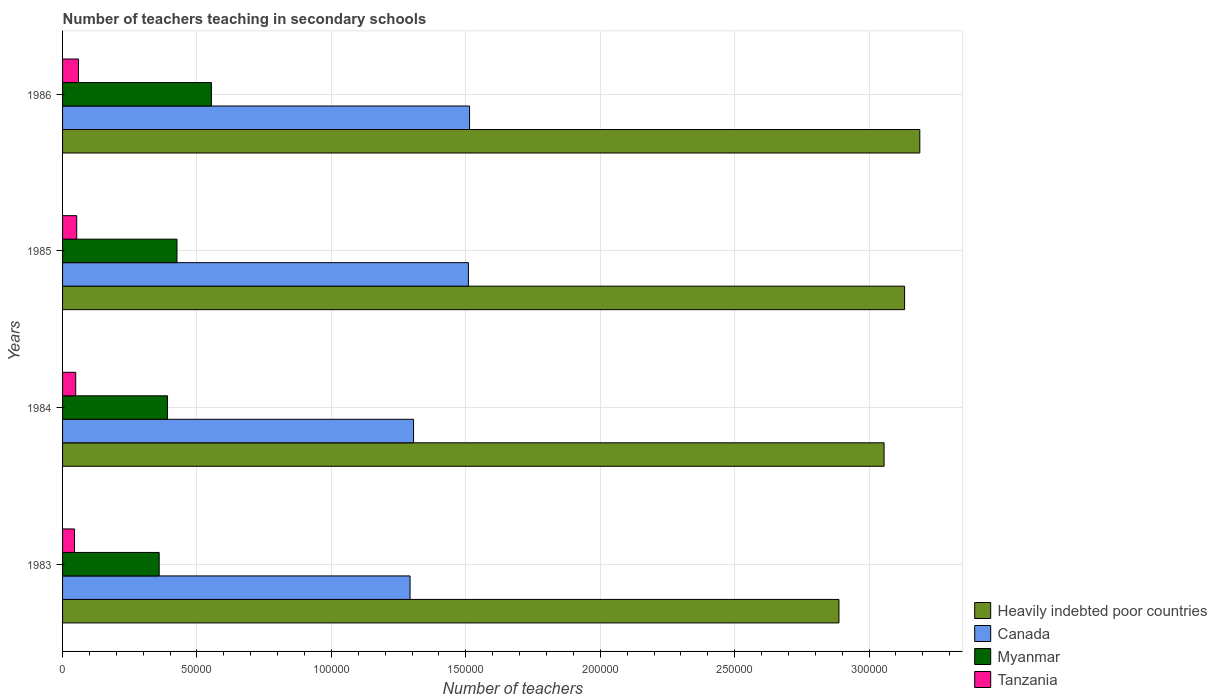How many different coloured bars are there?
Provide a succinct answer. 4. How many groups of bars are there?
Offer a terse response. 4. Are the number of bars per tick equal to the number of legend labels?
Provide a succinct answer. Yes. How many bars are there on the 3rd tick from the top?
Your answer should be very brief. 4. How many bars are there on the 2nd tick from the bottom?
Your answer should be compact. 4. What is the number of teachers teaching in secondary schools in Tanzania in 1983?
Provide a short and direct response. 4453. Across all years, what is the maximum number of teachers teaching in secondary schools in Canada?
Offer a very short reply. 1.51e+05. Across all years, what is the minimum number of teachers teaching in secondary schools in Tanzania?
Make the answer very short. 4453. In which year was the number of teachers teaching in secondary schools in Canada maximum?
Offer a terse response. 1986. What is the total number of teachers teaching in secondary schools in Heavily indebted poor countries in the graph?
Offer a very short reply. 1.23e+06. What is the difference between the number of teachers teaching in secondary schools in Heavily indebted poor countries in 1983 and that in 1985?
Your answer should be very brief. -2.44e+04. What is the difference between the number of teachers teaching in secondary schools in Heavily indebted poor countries in 1986 and the number of teachers teaching in secondary schools in Tanzania in 1984?
Provide a succinct answer. 3.14e+05. What is the average number of teachers teaching in secondary schools in Myanmar per year?
Ensure brevity in your answer.  4.32e+04. In the year 1983, what is the difference between the number of teachers teaching in secondary schools in Myanmar and number of teachers teaching in secondary schools in Heavily indebted poor countries?
Give a very brief answer. -2.53e+05. What is the ratio of the number of teachers teaching in secondary schools in Myanmar in 1983 to that in 1986?
Ensure brevity in your answer.  0.65. Is the number of teachers teaching in secondary schools in Myanmar in 1985 less than that in 1986?
Your response must be concise. Yes. Is the difference between the number of teachers teaching in secondary schools in Myanmar in 1983 and 1986 greater than the difference between the number of teachers teaching in secondary schools in Heavily indebted poor countries in 1983 and 1986?
Offer a very short reply. Yes. What is the difference between the highest and the second highest number of teachers teaching in secondary schools in Heavily indebted poor countries?
Your answer should be very brief. 5662.28. What is the difference between the highest and the lowest number of teachers teaching in secondary schools in Tanzania?
Your answer should be compact. 1464. In how many years, is the number of teachers teaching in secondary schools in Canada greater than the average number of teachers teaching in secondary schools in Canada taken over all years?
Provide a short and direct response. 2. Is it the case that in every year, the sum of the number of teachers teaching in secondary schools in Tanzania and number of teachers teaching in secondary schools in Heavily indebted poor countries is greater than the sum of number of teachers teaching in secondary schools in Canada and number of teachers teaching in secondary schools in Myanmar?
Your answer should be compact. No. What does the 3rd bar from the top in 1983 represents?
Your answer should be compact. Canada. What does the 1st bar from the bottom in 1985 represents?
Make the answer very short. Heavily indebted poor countries. How many bars are there?
Make the answer very short. 16. Are all the bars in the graph horizontal?
Offer a very short reply. Yes. Are the values on the major ticks of X-axis written in scientific E-notation?
Your answer should be very brief. No. Does the graph contain any zero values?
Your answer should be compact. No. Does the graph contain grids?
Your response must be concise. Yes. What is the title of the graph?
Provide a succinct answer. Number of teachers teaching in secondary schools. Does "Aruba" appear as one of the legend labels in the graph?
Offer a terse response. No. What is the label or title of the X-axis?
Provide a succinct answer. Number of teachers. What is the Number of teachers of Heavily indebted poor countries in 1983?
Provide a short and direct response. 2.89e+05. What is the Number of teachers of Canada in 1983?
Offer a very short reply. 1.29e+05. What is the Number of teachers of Myanmar in 1983?
Your answer should be very brief. 3.59e+04. What is the Number of teachers of Tanzania in 1983?
Provide a short and direct response. 4453. What is the Number of teachers in Heavily indebted poor countries in 1984?
Your response must be concise. 3.06e+05. What is the Number of teachers of Canada in 1984?
Your answer should be compact. 1.31e+05. What is the Number of teachers of Myanmar in 1984?
Your answer should be compact. 3.90e+04. What is the Number of teachers of Tanzania in 1984?
Provide a succinct answer. 4886. What is the Number of teachers in Heavily indebted poor countries in 1985?
Provide a succinct answer. 3.13e+05. What is the Number of teachers in Canada in 1985?
Make the answer very short. 1.51e+05. What is the Number of teachers of Myanmar in 1985?
Keep it short and to the point. 4.26e+04. What is the Number of teachers in Tanzania in 1985?
Offer a terse response. 5267. What is the Number of teachers in Heavily indebted poor countries in 1986?
Keep it short and to the point. 3.19e+05. What is the Number of teachers in Canada in 1986?
Offer a terse response. 1.51e+05. What is the Number of teachers in Myanmar in 1986?
Make the answer very short. 5.54e+04. What is the Number of teachers in Tanzania in 1986?
Your answer should be very brief. 5917. Across all years, what is the maximum Number of teachers of Heavily indebted poor countries?
Give a very brief answer. 3.19e+05. Across all years, what is the maximum Number of teachers of Canada?
Keep it short and to the point. 1.51e+05. Across all years, what is the maximum Number of teachers in Myanmar?
Give a very brief answer. 5.54e+04. Across all years, what is the maximum Number of teachers in Tanzania?
Your answer should be compact. 5917. Across all years, what is the minimum Number of teachers in Heavily indebted poor countries?
Make the answer very short. 2.89e+05. Across all years, what is the minimum Number of teachers in Canada?
Provide a succinct answer. 1.29e+05. Across all years, what is the minimum Number of teachers in Myanmar?
Your answer should be compact. 3.59e+04. Across all years, what is the minimum Number of teachers of Tanzania?
Your answer should be very brief. 4453. What is the total Number of teachers in Heavily indebted poor countries in the graph?
Your response must be concise. 1.23e+06. What is the total Number of teachers in Canada in the graph?
Your response must be concise. 5.62e+05. What is the total Number of teachers in Myanmar in the graph?
Offer a very short reply. 1.73e+05. What is the total Number of teachers in Tanzania in the graph?
Offer a terse response. 2.05e+04. What is the difference between the Number of teachers of Heavily indebted poor countries in 1983 and that in 1984?
Keep it short and to the point. -1.68e+04. What is the difference between the Number of teachers in Canada in 1983 and that in 1984?
Give a very brief answer. -1295. What is the difference between the Number of teachers of Myanmar in 1983 and that in 1984?
Provide a short and direct response. -3105. What is the difference between the Number of teachers in Tanzania in 1983 and that in 1984?
Provide a succinct answer. -433. What is the difference between the Number of teachers of Heavily indebted poor countries in 1983 and that in 1985?
Give a very brief answer. -2.44e+04. What is the difference between the Number of teachers of Canada in 1983 and that in 1985?
Your answer should be compact. -2.17e+04. What is the difference between the Number of teachers in Myanmar in 1983 and that in 1985?
Provide a short and direct response. -6617. What is the difference between the Number of teachers of Tanzania in 1983 and that in 1985?
Provide a short and direct response. -814. What is the difference between the Number of teachers in Heavily indebted poor countries in 1983 and that in 1986?
Your answer should be compact. -3.01e+04. What is the difference between the Number of teachers in Canada in 1983 and that in 1986?
Offer a very short reply. -2.21e+04. What is the difference between the Number of teachers of Myanmar in 1983 and that in 1986?
Your answer should be compact. -1.94e+04. What is the difference between the Number of teachers in Tanzania in 1983 and that in 1986?
Keep it short and to the point. -1464. What is the difference between the Number of teachers of Heavily indebted poor countries in 1984 and that in 1985?
Give a very brief answer. -7625.28. What is the difference between the Number of teachers in Canada in 1984 and that in 1985?
Provide a succinct answer. -2.04e+04. What is the difference between the Number of teachers in Myanmar in 1984 and that in 1985?
Ensure brevity in your answer.  -3512. What is the difference between the Number of teachers of Tanzania in 1984 and that in 1985?
Provide a succinct answer. -381. What is the difference between the Number of teachers in Heavily indebted poor countries in 1984 and that in 1986?
Your answer should be very brief. -1.33e+04. What is the difference between the Number of teachers in Canada in 1984 and that in 1986?
Offer a terse response. -2.08e+04. What is the difference between the Number of teachers of Myanmar in 1984 and that in 1986?
Provide a succinct answer. -1.63e+04. What is the difference between the Number of teachers of Tanzania in 1984 and that in 1986?
Your response must be concise. -1031. What is the difference between the Number of teachers of Heavily indebted poor countries in 1985 and that in 1986?
Your answer should be very brief. -5662.28. What is the difference between the Number of teachers of Canada in 1985 and that in 1986?
Your answer should be compact. -430. What is the difference between the Number of teachers of Myanmar in 1985 and that in 1986?
Keep it short and to the point. -1.28e+04. What is the difference between the Number of teachers in Tanzania in 1985 and that in 1986?
Your answer should be compact. -650. What is the difference between the Number of teachers in Heavily indebted poor countries in 1983 and the Number of teachers in Canada in 1984?
Keep it short and to the point. 1.58e+05. What is the difference between the Number of teachers in Heavily indebted poor countries in 1983 and the Number of teachers in Myanmar in 1984?
Offer a very short reply. 2.50e+05. What is the difference between the Number of teachers of Heavily indebted poor countries in 1983 and the Number of teachers of Tanzania in 1984?
Keep it short and to the point. 2.84e+05. What is the difference between the Number of teachers of Canada in 1983 and the Number of teachers of Myanmar in 1984?
Offer a terse response. 9.02e+04. What is the difference between the Number of teachers of Canada in 1983 and the Number of teachers of Tanzania in 1984?
Provide a succinct answer. 1.24e+05. What is the difference between the Number of teachers of Myanmar in 1983 and the Number of teachers of Tanzania in 1984?
Keep it short and to the point. 3.11e+04. What is the difference between the Number of teachers in Heavily indebted poor countries in 1983 and the Number of teachers in Canada in 1985?
Make the answer very short. 1.38e+05. What is the difference between the Number of teachers of Heavily indebted poor countries in 1983 and the Number of teachers of Myanmar in 1985?
Ensure brevity in your answer.  2.46e+05. What is the difference between the Number of teachers in Heavily indebted poor countries in 1983 and the Number of teachers in Tanzania in 1985?
Offer a terse response. 2.84e+05. What is the difference between the Number of teachers of Canada in 1983 and the Number of teachers of Myanmar in 1985?
Keep it short and to the point. 8.67e+04. What is the difference between the Number of teachers in Canada in 1983 and the Number of teachers in Tanzania in 1985?
Offer a terse response. 1.24e+05. What is the difference between the Number of teachers of Myanmar in 1983 and the Number of teachers of Tanzania in 1985?
Offer a terse response. 3.07e+04. What is the difference between the Number of teachers of Heavily indebted poor countries in 1983 and the Number of teachers of Canada in 1986?
Make the answer very short. 1.37e+05. What is the difference between the Number of teachers of Heavily indebted poor countries in 1983 and the Number of teachers of Myanmar in 1986?
Your answer should be very brief. 2.33e+05. What is the difference between the Number of teachers of Heavily indebted poor countries in 1983 and the Number of teachers of Tanzania in 1986?
Your response must be concise. 2.83e+05. What is the difference between the Number of teachers in Canada in 1983 and the Number of teachers in Myanmar in 1986?
Your answer should be compact. 7.39e+04. What is the difference between the Number of teachers of Canada in 1983 and the Number of teachers of Tanzania in 1986?
Provide a short and direct response. 1.23e+05. What is the difference between the Number of teachers of Myanmar in 1983 and the Number of teachers of Tanzania in 1986?
Offer a terse response. 3.00e+04. What is the difference between the Number of teachers of Heavily indebted poor countries in 1984 and the Number of teachers of Canada in 1985?
Keep it short and to the point. 1.55e+05. What is the difference between the Number of teachers of Heavily indebted poor countries in 1984 and the Number of teachers of Myanmar in 1985?
Your answer should be very brief. 2.63e+05. What is the difference between the Number of teachers in Heavily indebted poor countries in 1984 and the Number of teachers in Tanzania in 1985?
Make the answer very short. 3.00e+05. What is the difference between the Number of teachers in Canada in 1984 and the Number of teachers in Myanmar in 1985?
Your response must be concise. 8.80e+04. What is the difference between the Number of teachers of Canada in 1984 and the Number of teachers of Tanzania in 1985?
Give a very brief answer. 1.25e+05. What is the difference between the Number of teachers in Myanmar in 1984 and the Number of teachers in Tanzania in 1985?
Provide a succinct answer. 3.38e+04. What is the difference between the Number of teachers of Heavily indebted poor countries in 1984 and the Number of teachers of Canada in 1986?
Ensure brevity in your answer.  1.54e+05. What is the difference between the Number of teachers of Heavily indebted poor countries in 1984 and the Number of teachers of Myanmar in 1986?
Give a very brief answer. 2.50e+05. What is the difference between the Number of teachers in Heavily indebted poor countries in 1984 and the Number of teachers in Tanzania in 1986?
Your response must be concise. 3.00e+05. What is the difference between the Number of teachers of Canada in 1984 and the Number of teachers of Myanmar in 1986?
Give a very brief answer. 7.52e+04. What is the difference between the Number of teachers of Canada in 1984 and the Number of teachers of Tanzania in 1986?
Your answer should be very brief. 1.25e+05. What is the difference between the Number of teachers in Myanmar in 1984 and the Number of teachers in Tanzania in 1986?
Keep it short and to the point. 3.31e+04. What is the difference between the Number of teachers in Heavily indebted poor countries in 1985 and the Number of teachers in Canada in 1986?
Ensure brevity in your answer.  1.62e+05. What is the difference between the Number of teachers in Heavily indebted poor countries in 1985 and the Number of teachers in Myanmar in 1986?
Your answer should be compact. 2.58e+05. What is the difference between the Number of teachers of Heavily indebted poor countries in 1985 and the Number of teachers of Tanzania in 1986?
Provide a short and direct response. 3.07e+05. What is the difference between the Number of teachers of Canada in 1985 and the Number of teachers of Myanmar in 1986?
Provide a succinct answer. 9.56e+04. What is the difference between the Number of teachers of Canada in 1985 and the Number of teachers of Tanzania in 1986?
Your answer should be very brief. 1.45e+05. What is the difference between the Number of teachers of Myanmar in 1985 and the Number of teachers of Tanzania in 1986?
Make the answer very short. 3.66e+04. What is the average Number of teachers in Heavily indebted poor countries per year?
Provide a short and direct response. 3.07e+05. What is the average Number of teachers of Canada per year?
Give a very brief answer. 1.41e+05. What is the average Number of teachers in Myanmar per year?
Keep it short and to the point. 4.32e+04. What is the average Number of teachers in Tanzania per year?
Provide a succinct answer. 5130.75. In the year 1983, what is the difference between the Number of teachers in Heavily indebted poor countries and Number of teachers in Canada?
Keep it short and to the point. 1.60e+05. In the year 1983, what is the difference between the Number of teachers of Heavily indebted poor countries and Number of teachers of Myanmar?
Offer a terse response. 2.53e+05. In the year 1983, what is the difference between the Number of teachers of Heavily indebted poor countries and Number of teachers of Tanzania?
Your response must be concise. 2.84e+05. In the year 1983, what is the difference between the Number of teachers in Canada and Number of teachers in Myanmar?
Your response must be concise. 9.33e+04. In the year 1983, what is the difference between the Number of teachers in Canada and Number of teachers in Tanzania?
Your answer should be compact. 1.25e+05. In the year 1983, what is the difference between the Number of teachers in Myanmar and Number of teachers in Tanzania?
Keep it short and to the point. 3.15e+04. In the year 1984, what is the difference between the Number of teachers of Heavily indebted poor countries and Number of teachers of Canada?
Provide a succinct answer. 1.75e+05. In the year 1984, what is the difference between the Number of teachers of Heavily indebted poor countries and Number of teachers of Myanmar?
Offer a terse response. 2.67e+05. In the year 1984, what is the difference between the Number of teachers in Heavily indebted poor countries and Number of teachers in Tanzania?
Keep it short and to the point. 3.01e+05. In the year 1984, what is the difference between the Number of teachers of Canada and Number of teachers of Myanmar?
Keep it short and to the point. 9.15e+04. In the year 1984, what is the difference between the Number of teachers in Canada and Number of teachers in Tanzania?
Offer a very short reply. 1.26e+05. In the year 1984, what is the difference between the Number of teachers of Myanmar and Number of teachers of Tanzania?
Offer a very short reply. 3.42e+04. In the year 1985, what is the difference between the Number of teachers of Heavily indebted poor countries and Number of teachers of Canada?
Your response must be concise. 1.62e+05. In the year 1985, what is the difference between the Number of teachers of Heavily indebted poor countries and Number of teachers of Myanmar?
Offer a very short reply. 2.71e+05. In the year 1985, what is the difference between the Number of teachers in Heavily indebted poor countries and Number of teachers in Tanzania?
Offer a very short reply. 3.08e+05. In the year 1985, what is the difference between the Number of teachers in Canada and Number of teachers in Myanmar?
Your answer should be compact. 1.08e+05. In the year 1985, what is the difference between the Number of teachers of Canada and Number of teachers of Tanzania?
Provide a short and direct response. 1.46e+05. In the year 1985, what is the difference between the Number of teachers of Myanmar and Number of teachers of Tanzania?
Offer a very short reply. 3.73e+04. In the year 1986, what is the difference between the Number of teachers in Heavily indebted poor countries and Number of teachers in Canada?
Your response must be concise. 1.67e+05. In the year 1986, what is the difference between the Number of teachers in Heavily indebted poor countries and Number of teachers in Myanmar?
Keep it short and to the point. 2.64e+05. In the year 1986, what is the difference between the Number of teachers in Heavily indebted poor countries and Number of teachers in Tanzania?
Provide a succinct answer. 3.13e+05. In the year 1986, what is the difference between the Number of teachers of Canada and Number of teachers of Myanmar?
Offer a very short reply. 9.60e+04. In the year 1986, what is the difference between the Number of teachers of Canada and Number of teachers of Tanzania?
Your response must be concise. 1.45e+05. In the year 1986, what is the difference between the Number of teachers of Myanmar and Number of teachers of Tanzania?
Ensure brevity in your answer.  4.94e+04. What is the ratio of the Number of teachers of Heavily indebted poor countries in 1983 to that in 1984?
Give a very brief answer. 0.95. What is the ratio of the Number of teachers of Myanmar in 1983 to that in 1984?
Offer a very short reply. 0.92. What is the ratio of the Number of teachers of Tanzania in 1983 to that in 1984?
Your answer should be compact. 0.91. What is the ratio of the Number of teachers in Heavily indebted poor countries in 1983 to that in 1985?
Offer a terse response. 0.92. What is the ratio of the Number of teachers in Canada in 1983 to that in 1985?
Keep it short and to the point. 0.86. What is the ratio of the Number of teachers in Myanmar in 1983 to that in 1985?
Make the answer very short. 0.84. What is the ratio of the Number of teachers in Tanzania in 1983 to that in 1985?
Your response must be concise. 0.85. What is the ratio of the Number of teachers of Heavily indebted poor countries in 1983 to that in 1986?
Offer a very short reply. 0.91. What is the ratio of the Number of teachers of Canada in 1983 to that in 1986?
Offer a terse response. 0.85. What is the ratio of the Number of teachers of Myanmar in 1983 to that in 1986?
Offer a very short reply. 0.65. What is the ratio of the Number of teachers in Tanzania in 1983 to that in 1986?
Make the answer very short. 0.75. What is the ratio of the Number of teachers of Heavily indebted poor countries in 1984 to that in 1985?
Offer a terse response. 0.98. What is the ratio of the Number of teachers in Canada in 1984 to that in 1985?
Keep it short and to the point. 0.86. What is the ratio of the Number of teachers of Myanmar in 1984 to that in 1985?
Ensure brevity in your answer.  0.92. What is the ratio of the Number of teachers in Tanzania in 1984 to that in 1985?
Make the answer very short. 0.93. What is the ratio of the Number of teachers in Canada in 1984 to that in 1986?
Keep it short and to the point. 0.86. What is the ratio of the Number of teachers in Myanmar in 1984 to that in 1986?
Keep it short and to the point. 0.71. What is the ratio of the Number of teachers of Tanzania in 1984 to that in 1986?
Offer a terse response. 0.83. What is the ratio of the Number of teachers in Heavily indebted poor countries in 1985 to that in 1986?
Provide a succinct answer. 0.98. What is the ratio of the Number of teachers of Myanmar in 1985 to that in 1986?
Your answer should be very brief. 0.77. What is the ratio of the Number of teachers of Tanzania in 1985 to that in 1986?
Keep it short and to the point. 0.89. What is the difference between the highest and the second highest Number of teachers in Heavily indebted poor countries?
Provide a succinct answer. 5662.28. What is the difference between the highest and the second highest Number of teachers in Canada?
Your answer should be compact. 430. What is the difference between the highest and the second highest Number of teachers of Myanmar?
Provide a succinct answer. 1.28e+04. What is the difference between the highest and the second highest Number of teachers of Tanzania?
Provide a succinct answer. 650. What is the difference between the highest and the lowest Number of teachers of Heavily indebted poor countries?
Ensure brevity in your answer.  3.01e+04. What is the difference between the highest and the lowest Number of teachers of Canada?
Give a very brief answer. 2.21e+04. What is the difference between the highest and the lowest Number of teachers of Myanmar?
Keep it short and to the point. 1.94e+04. What is the difference between the highest and the lowest Number of teachers of Tanzania?
Make the answer very short. 1464. 